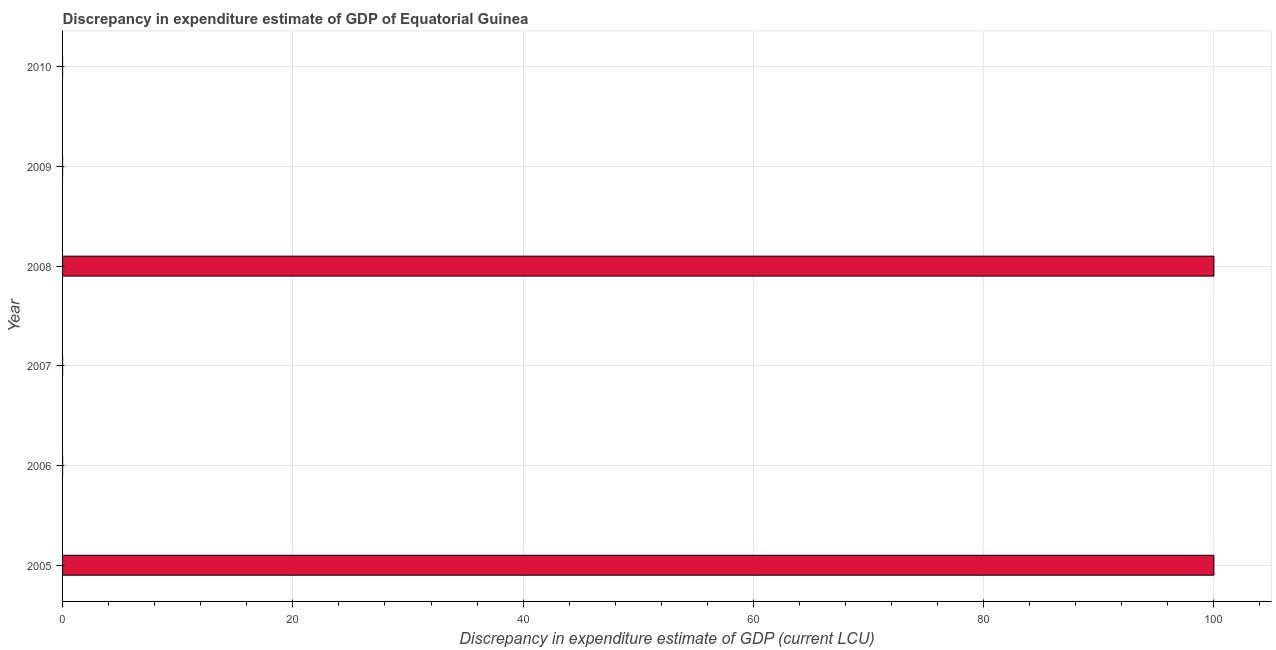Does the graph contain grids?
Ensure brevity in your answer.  Yes. What is the title of the graph?
Ensure brevity in your answer.  Discrepancy in expenditure estimate of GDP of Equatorial Guinea. What is the label or title of the X-axis?
Ensure brevity in your answer.  Discrepancy in expenditure estimate of GDP (current LCU). What is the discrepancy in expenditure estimate of gdp in 2009?
Your answer should be very brief. 0. Across all years, what is the maximum discrepancy in expenditure estimate of gdp?
Make the answer very short. 100. Across all years, what is the minimum discrepancy in expenditure estimate of gdp?
Your response must be concise. 0. In which year was the discrepancy in expenditure estimate of gdp maximum?
Your answer should be very brief. 2005. What is the sum of the discrepancy in expenditure estimate of gdp?
Keep it short and to the point. 200. What is the difference between the discrepancy in expenditure estimate of gdp in 2006 and 2008?
Make the answer very short. -100. What is the average discrepancy in expenditure estimate of gdp per year?
Provide a short and direct response. 33.33. What is the median discrepancy in expenditure estimate of gdp?
Offer a terse response. 0. In how many years, is the discrepancy in expenditure estimate of gdp greater than 32 LCU?
Give a very brief answer. 2. What is the ratio of the discrepancy in expenditure estimate of gdp in 2005 to that in 2007?
Provide a succinct answer. 2.15e+05. Is the discrepancy in expenditure estimate of gdp in 2008 less than that in 2009?
Offer a very short reply. No. What is the difference between the highest and the second highest discrepancy in expenditure estimate of gdp?
Provide a succinct answer. 0. Is the sum of the discrepancy in expenditure estimate of gdp in 2007 and 2008 greater than the maximum discrepancy in expenditure estimate of gdp across all years?
Keep it short and to the point. Yes. What is the difference between the highest and the lowest discrepancy in expenditure estimate of gdp?
Provide a succinct answer. 100. How many bars are there?
Ensure brevity in your answer.  5. How many years are there in the graph?
Make the answer very short. 6. Are the values on the major ticks of X-axis written in scientific E-notation?
Your response must be concise. No. What is the Discrepancy in expenditure estimate of GDP (current LCU) of 2005?
Your answer should be very brief. 100. What is the Discrepancy in expenditure estimate of GDP (current LCU) of 2006?
Provide a succinct answer. 0. What is the Discrepancy in expenditure estimate of GDP (current LCU) of 2007?
Your response must be concise. 0. What is the Discrepancy in expenditure estimate of GDP (current LCU) in 2008?
Make the answer very short. 100. What is the Discrepancy in expenditure estimate of GDP (current LCU) in 2009?
Your answer should be compact. 0. What is the Discrepancy in expenditure estimate of GDP (current LCU) in 2010?
Provide a succinct answer. 0. What is the difference between the Discrepancy in expenditure estimate of GDP (current LCU) in 2005 and 2006?
Your response must be concise. 100. What is the difference between the Discrepancy in expenditure estimate of GDP (current LCU) in 2005 and 2007?
Ensure brevity in your answer.  100. What is the difference between the Discrepancy in expenditure estimate of GDP (current LCU) in 2005 and 2008?
Give a very brief answer. 0. What is the difference between the Discrepancy in expenditure estimate of GDP (current LCU) in 2005 and 2009?
Keep it short and to the point. 100. What is the difference between the Discrepancy in expenditure estimate of GDP (current LCU) in 2006 and 2007?
Offer a very short reply. 0. What is the difference between the Discrepancy in expenditure estimate of GDP (current LCU) in 2006 and 2008?
Your answer should be compact. -100. What is the difference between the Discrepancy in expenditure estimate of GDP (current LCU) in 2006 and 2009?
Your response must be concise. 0. What is the difference between the Discrepancy in expenditure estimate of GDP (current LCU) in 2007 and 2008?
Your answer should be compact. -100. What is the difference between the Discrepancy in expenditure estimate of GDP (current LCU) in 2007 and 2009?
Provide a short and direct response. 0. What is the difference between the Discrepancy in expenditure estimate of GDP (current LCU) in 2008 and 2009?
Ensure brevity in your answer.  100. What is the ratio of the Discrepancy in expenditure estimate of GDP (current LCU) in 2005 to that in 2006?
Your answer should be compact. 1.72e+05. What is the ratio of the Discrepancy in expenditure estimate of GDP (current LCU) in 2005 to that in 2007?
Ensure brevity in your answer.  2.15e+05. What is the ratio of the Discrepancy in expenditure estimate of GDP (current LCU) in 2005 to that in 2008?
Offer a terse response. 1. What is the ratio of the Discrepancy in expenditure estimate of GDP (current LCU) in 2005 to that in 2009?
Your answer should be very brief. 2.86e+05. What is the ratio of the Discrepancy in expenditure estimate of GDP (current LCU) in 2006 to that in 2008?
Provide a short and direct response. 0. What is the ratio of the Discrepancy in expenditure estimate of GDP (current LCU) in 2006 to that in 2009?
Offer a terse response. 1.67. What is the ratio of the Discrepancy in expenditure estimate of GDP (current LCU) in 2007 to that in 2008?
Give a very brief answer. 0. What is the ratio of the Discrepancy in expenditure estimate of GDP (current LCU) in 2007 to that in 2009?
Your answer should be compact. 1.33. What is the ratio of the Discrepancy in expenditure estimate of GDP (current LCU) in 2008 to that in 2009?
Your answer should be very brief. 2.86e+05. 